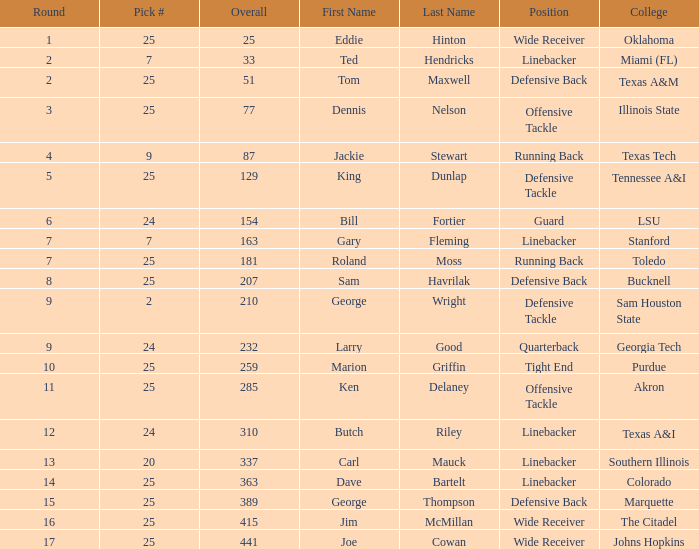Pick # of 25, and an Overall of 207 has what name? Sam Havrilak. 